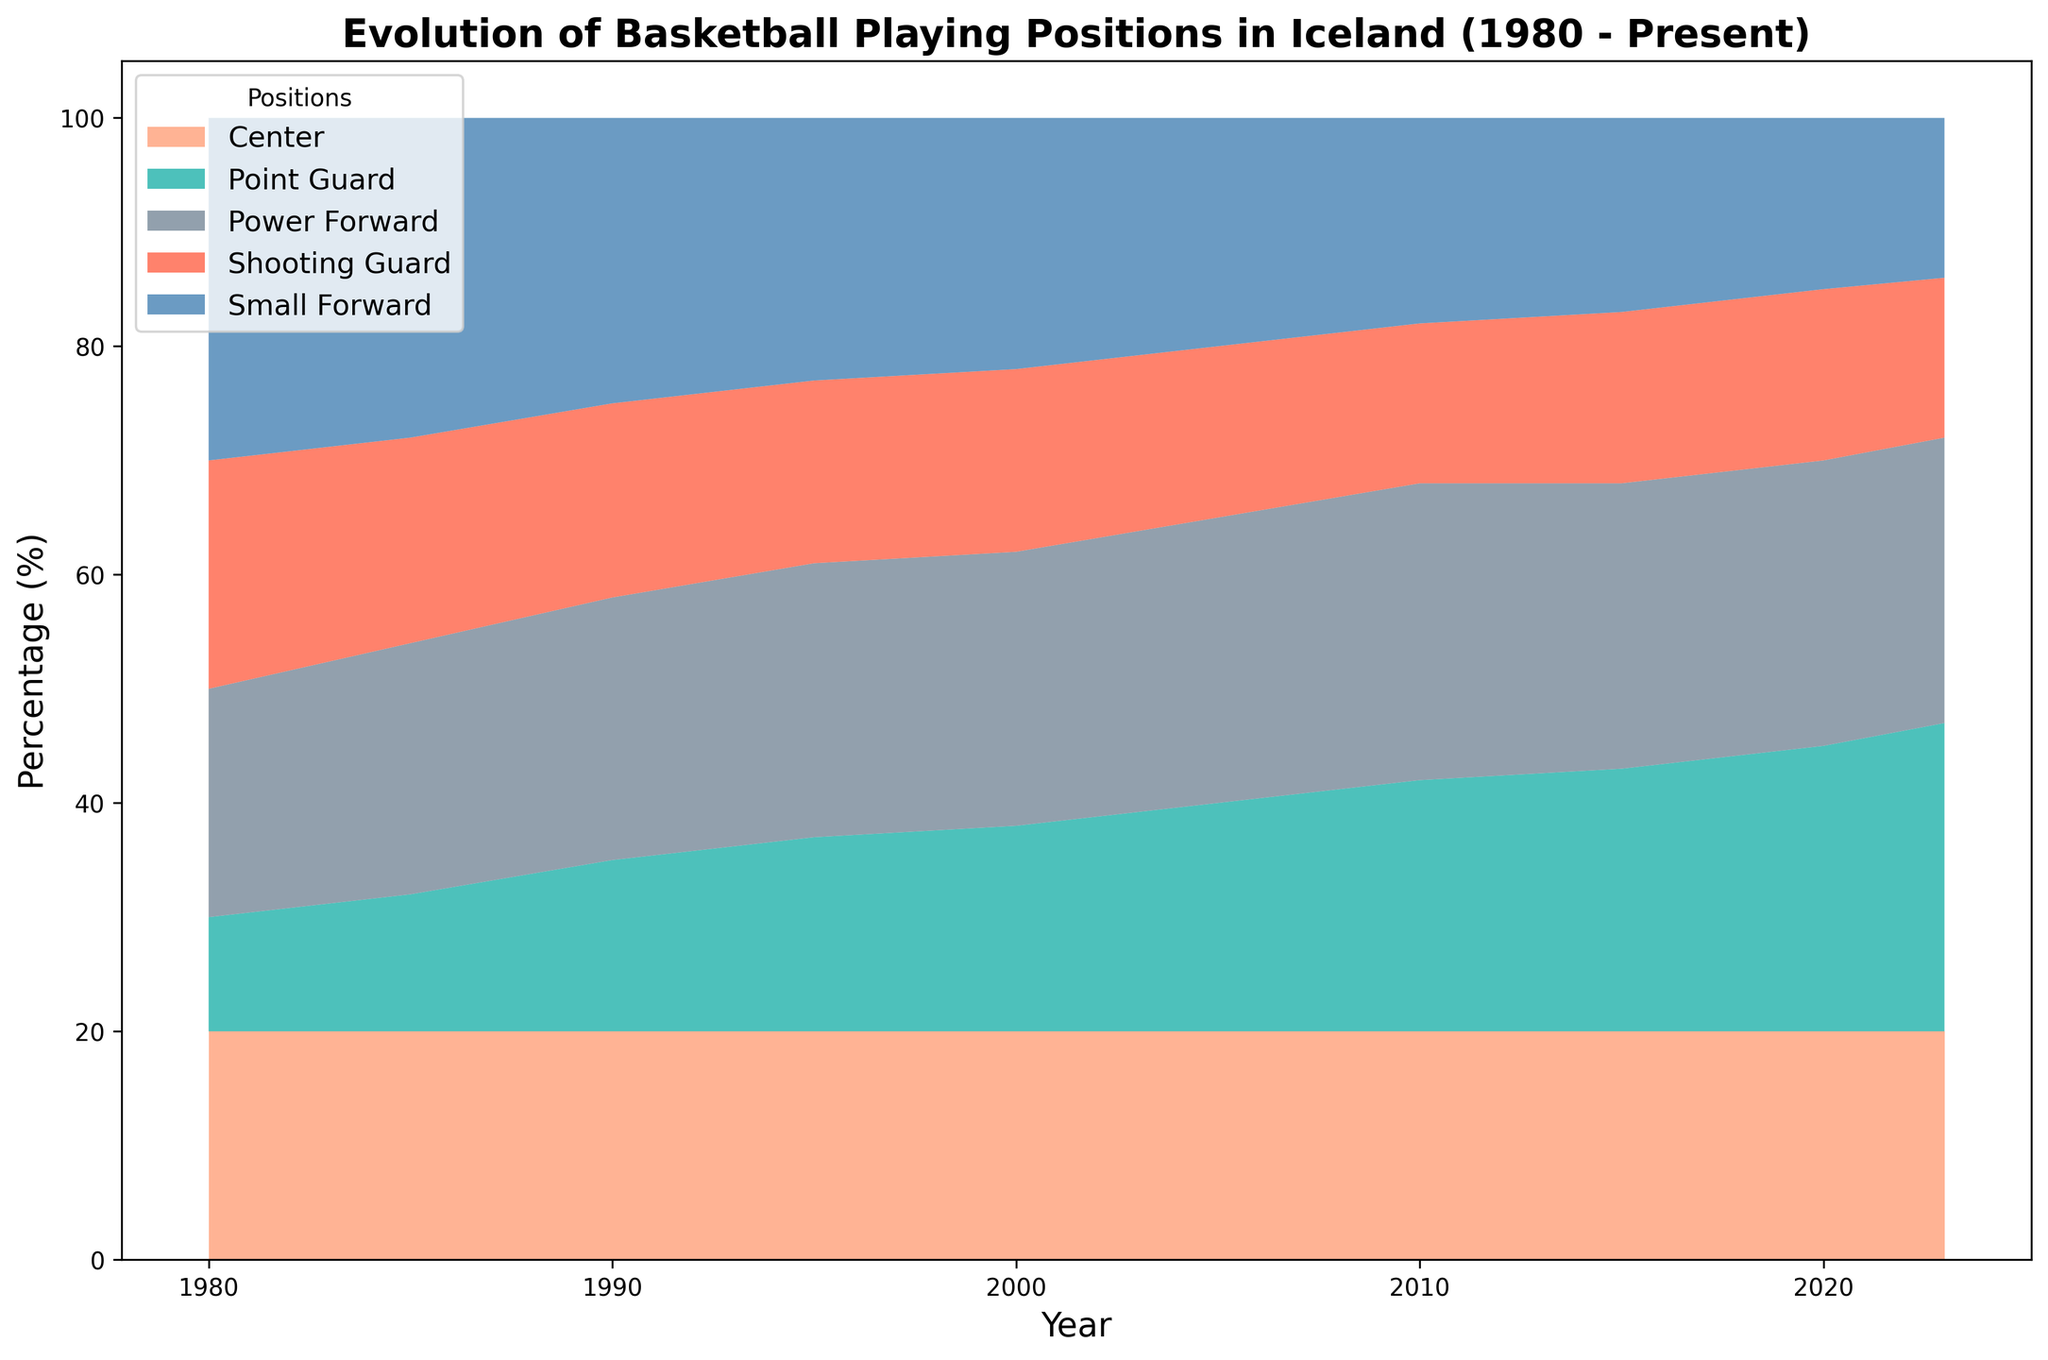What was the percentage of players in the Point Guard and Center positions in 1980? To find the total percentage of players in the Point Guard and Center positions in 1980, refer to the chart values for that year: Point Guard (10%) and Center (20%). Add these values together: 10% + 20% = 30%.
Answer: 30% Which position saw the most significant increase in its percentage from 1980 to 2023? To identify the position with the most significant increase, compare the values from 1980 and 2023 for each position. Point Guard increased from 10% in 1980 to 27% in 2023, which is the most significant change (27% - 10% = 17%).
Answer: Point Guard Between 2010 and 2023, did the percentage of Small Forwards increase or decrease? Look at the chart data for Small Forwards in 2010 (18%) and 2023 (14%). Comparing these values, there is a decrease: 18% - 14% = 4%.
Answer: Decrease In which year was the percentage of Shooting Guards at its lowest? By observing the values over the years, the lowest percentage for Shooting Guards is noticed in 2023 with 14%.
Answer: 2023 What is the average percentage of Power Forwards across all recorded years? To calculate the average percentage of Power Forwards, add the percentages for each year and divide by the total number of years: (20% + 22% + 23% + 24% + 24% + 25% + 26% + 25% + 25% + 25%) / 10 = 23.9%.
Answer: 23.9% From the chart, which position maintained the most consistent percentage around 20% throughout the years? Analyzing the data, Center position remained around 20% with minor fluctuations, e.g., always at 20%.
Answer: Center Which two positions had the largest combined percentage in 1995? Look at the chart data for 1995: the two positions with the largest values are Small Forward (23%) and Power Forward (24%). Combined percentage: 23% + 24% = 47%.
Answer: Small Forward and Power Forward Identify one year in which the percentage of Point Guards was exactly double the percentage of Shooting Guards. In 2005, the percentage for Point Guards was 20%, and for Shooting Guards, it was 10%, whereby 20% is exactly double of 10%.
Answer: 2005 Based on the figure, has the role of Small Forwards increased or decreased the most over the years? Comparing the highest point in 1980 (30%) and the value in 2023 (14%), the role of Small Forwards has notably decreased (30% - 14% = 16%).
Answer: Decreased How many years saw a steady percentage (no change) for Centers? Examining the chart, the percentage for Centers remained at 20% throughout all recorded years (10 years).
Answer: 10 